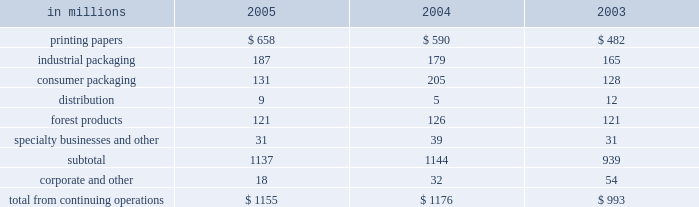Management believes it is important for interna- tional paper to maintain an investment-grade credit rat- ing to facilitate access to capital markets on favorable terms .
At december 31 , 2005 , the company held long- term credit ratings of bbb ( negative outlook ) and baa3 ( stable outlook ) from standard & poor 2019s and moody 2019s investor services , respectively .
Cash provided by operations cash provided by continuing operations totaled $ 1.5 billion for 2005 , compared with $ 2.1 billion in 2004 and $ 1.5 billion in 2003 .
The major components of cash provided by continuing operations are earnings from continuing operations adjusted for non-cash in- come and expense items and changes in working capital .
Earnings from continuing operations adjusted for non-cash items declined by $ 83 million in 2005 versus 2004 .
This compared with an increase of $ 612 million for 2004 over 2003 .
Working capital , representing international paper 2019s investments in accounts receivable and inventory less accounts payable and accrued liabilities , was $ 2.6 billion at december 31 , 2005 .
Cash used for working capital components increased by $ 591 million in 2005 , com- pared with a $ 86 million increase in 2004 and an $ 11 million increase in 2003 .
The increase in 2005 was principally due to a decline in accrued liabilities at de- cember 31 , 2005 .
Investment activities capital spending from continuing operations was $ 1.2 billion in 2005 , or 84% ( 84 % ) of depreciation and amor- tization , comparable to the $ 1.2 billion , or 87% ( 87 % ) of depreciation and amortization in 2004 , and $ 1.0 billion , or 74% ( 74 % ) of depreciation and amortization in 2003 .
The table presents capital spending from continuing operations by each of our business segments for the years ended december 31 , 2005 , 2004 and 2003 .
In millions 2005 2004 2003 .
We expect capital expenditures in 2006 to be about $ 1.2 billion , or about 80% ( 80 % ) of depreciation and amor- tization .
We will continue to focus our future capital spending on improving our key platform businesses in north america and on investments in geographic areas with strong growth opportunities .
Acquisitions in october 2005 , international paper acquired ap- proximately 65% ( 65 % ) of compagnie marocaine des cartons et des papiers ( cmcp ) , a leading moroccan corrugated packaging company , for approximately $ 80 million in cash plus assumed debt of approximately $ 40 million .
In august 2005 , pursuant to an existing agreement , international paper purchased a 50% ( 50 % ) third-party interest in ippm ( subsequently renamed international paper distribution limited ) for $ 46 million to facilitate possi- ble further growth in asian markets .
In 2001 , interna- tional paper had acquired a 25% ( 25 % ) interest in this business .
The accompanying consolidated balance sheet as of december 31 , 2005 includes preliminary estimates of the fair values of the assets and liabilities acquired , including approximately $ 50 million of goodwill .
In july 2004 , international paper acquired box usa holdings , inc .
( box usa ) for approximately $ 400 million , including the assumption of approximately $ 197 million of debt , of which approximately $ 193 mil- lion was repaid by july 31 , 2004 .
Each of the above acquisitions was accounted for using the purchase method .
The operating results of these acquisitions have been included in the con- solidated statement of operations from the dates of ac- quisition .
Financing activities 2005 : financing activities during 2005 included debt issuances of $ 1.0 billion and retirements of $ 2.7 billion , for a net debt and preferred securities reduction of $ 1.7 billion .
In november and december 2005 , international paper investments ( luxembourg ) s.ar.l. , a wholly- owned subsidiary of international paper , issued $ 700 million of long-term debt with an initial interest rate of libor plus 40 basis points that can vary depending upon the credit rating of the company , and a maturity date in november 2010 .
Additionally , the subsidiary borrowed $ 70 million under a bank credit agreement with an initial interest rate of libor plus 40 basis points that can vary depending upon the credit rating of the company , and a maturity date in november 2006 .
In december 2005 , international paper used pro- ceeds from the above borrowings , and from the sale of chh in the third quarter of 2005 , to repay approx- imately $ 190 million of notes with coupon rates ranging from 3.8% ( 3.8 % ) to 10% ( 10 % ) and original maturities from 2008 to 2029 .
The remaining proceeds from the borrowings and the chh sale will be used for further debt reductions in the first quarter of 2006. .
What was the ratio of the increase in the cash used for the working capital from 2004 to 2005? 
Computations: (591 / 86)
Answer: 6.87209. 